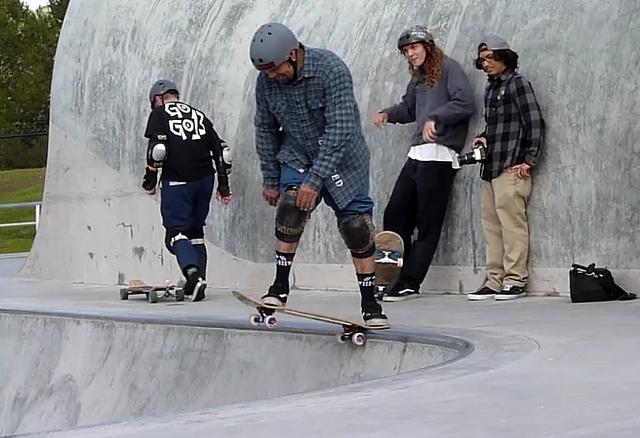How many of them are wearing helmets?
Be succinct. 3. What are the people doing?
Short answer required. Skateboarding. How many people are leaning against the wall?
Write a very short answer. 2. 